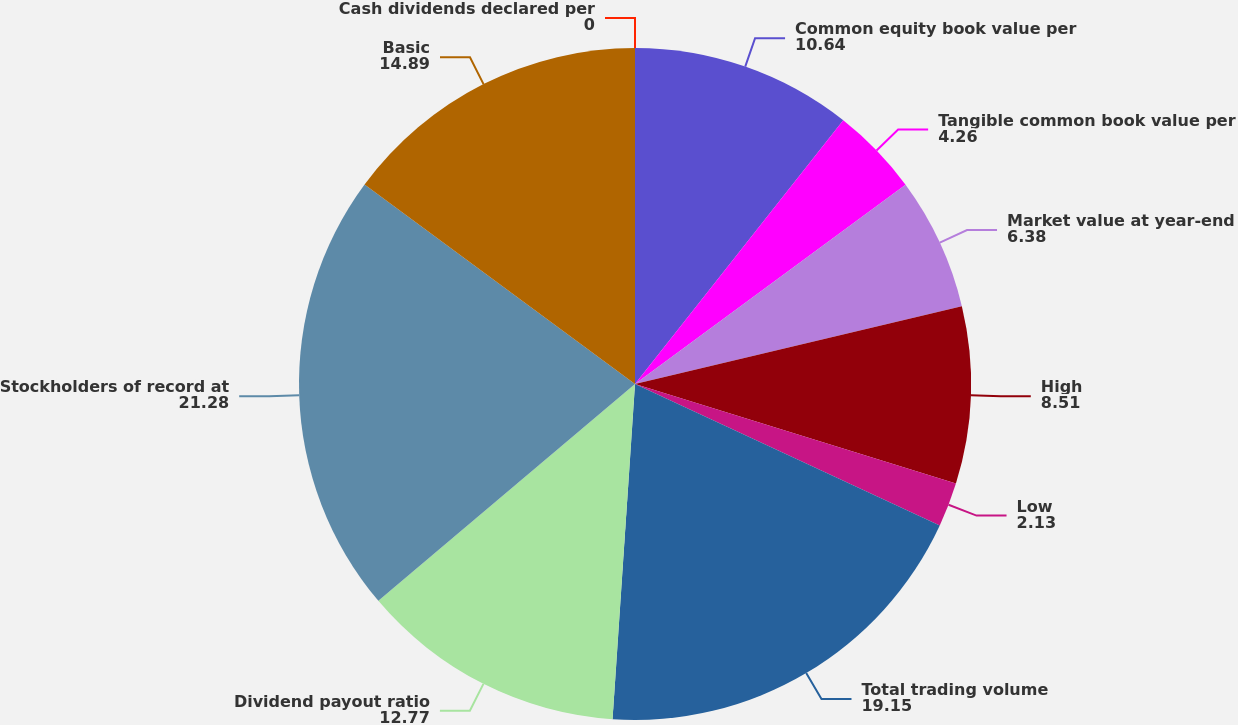Convert chart. <chart><loc_0><loc_0><loc_500><loc_500><pie_chart><fcel>Cash dividends declared per<fcel>Common equity book value per<fcel>Tangible common book value per<fcel>Market value at year-end<fcel>High<fcel>Low<fcel>Total trading volume<fcel>Dividend payout ratio<fcel>Stockholders of record at<fcel>Basic<nl><fcel>0.0%<fcel>10.64%<fcel>4.26%<fcel>6.38%<fcel>8.51%<fcel>2.13%<fcel>19.15%<fcel>12.77%<fcel>21.28%<fcel>14.89%<nl></chart> 